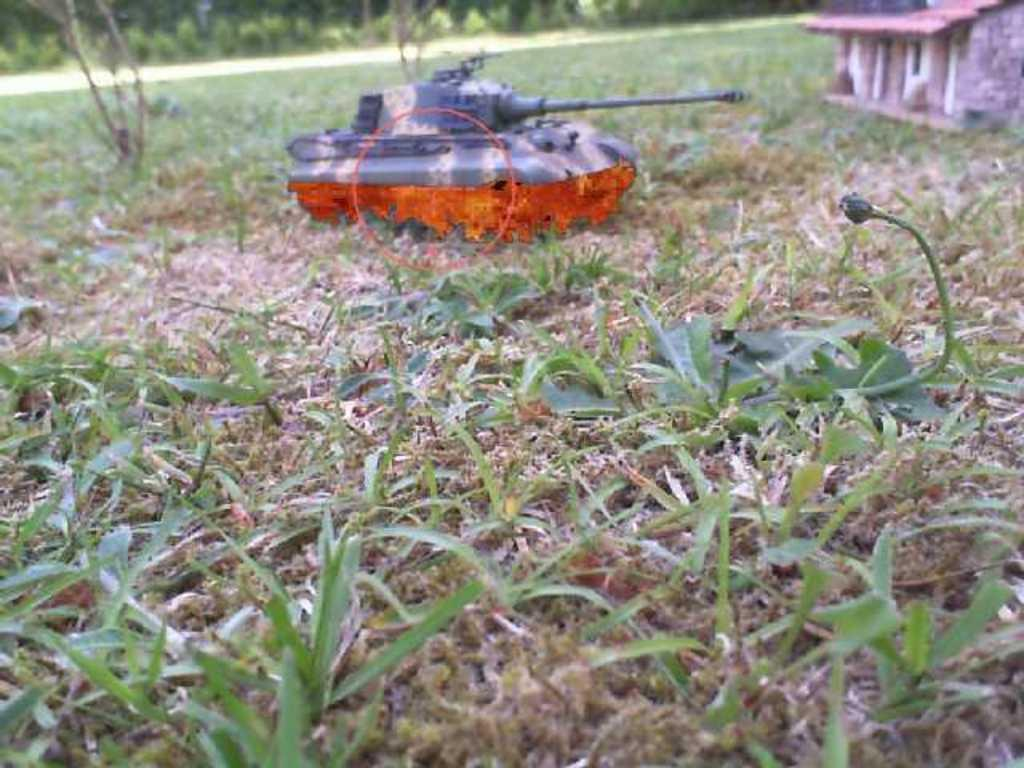What type of vegetation can be seen in the image? There are plants and grass in the image. What structure is visible in the image? There is a house in the image. What is the military vehicle present in the image? There is a military tank in the image. What can be seen in the background of the image? There are plants in the background of the image. What is the governor's reaction to the development in the image? There is no governor or development mentioned in the image, so it is not possible to answer this question. 